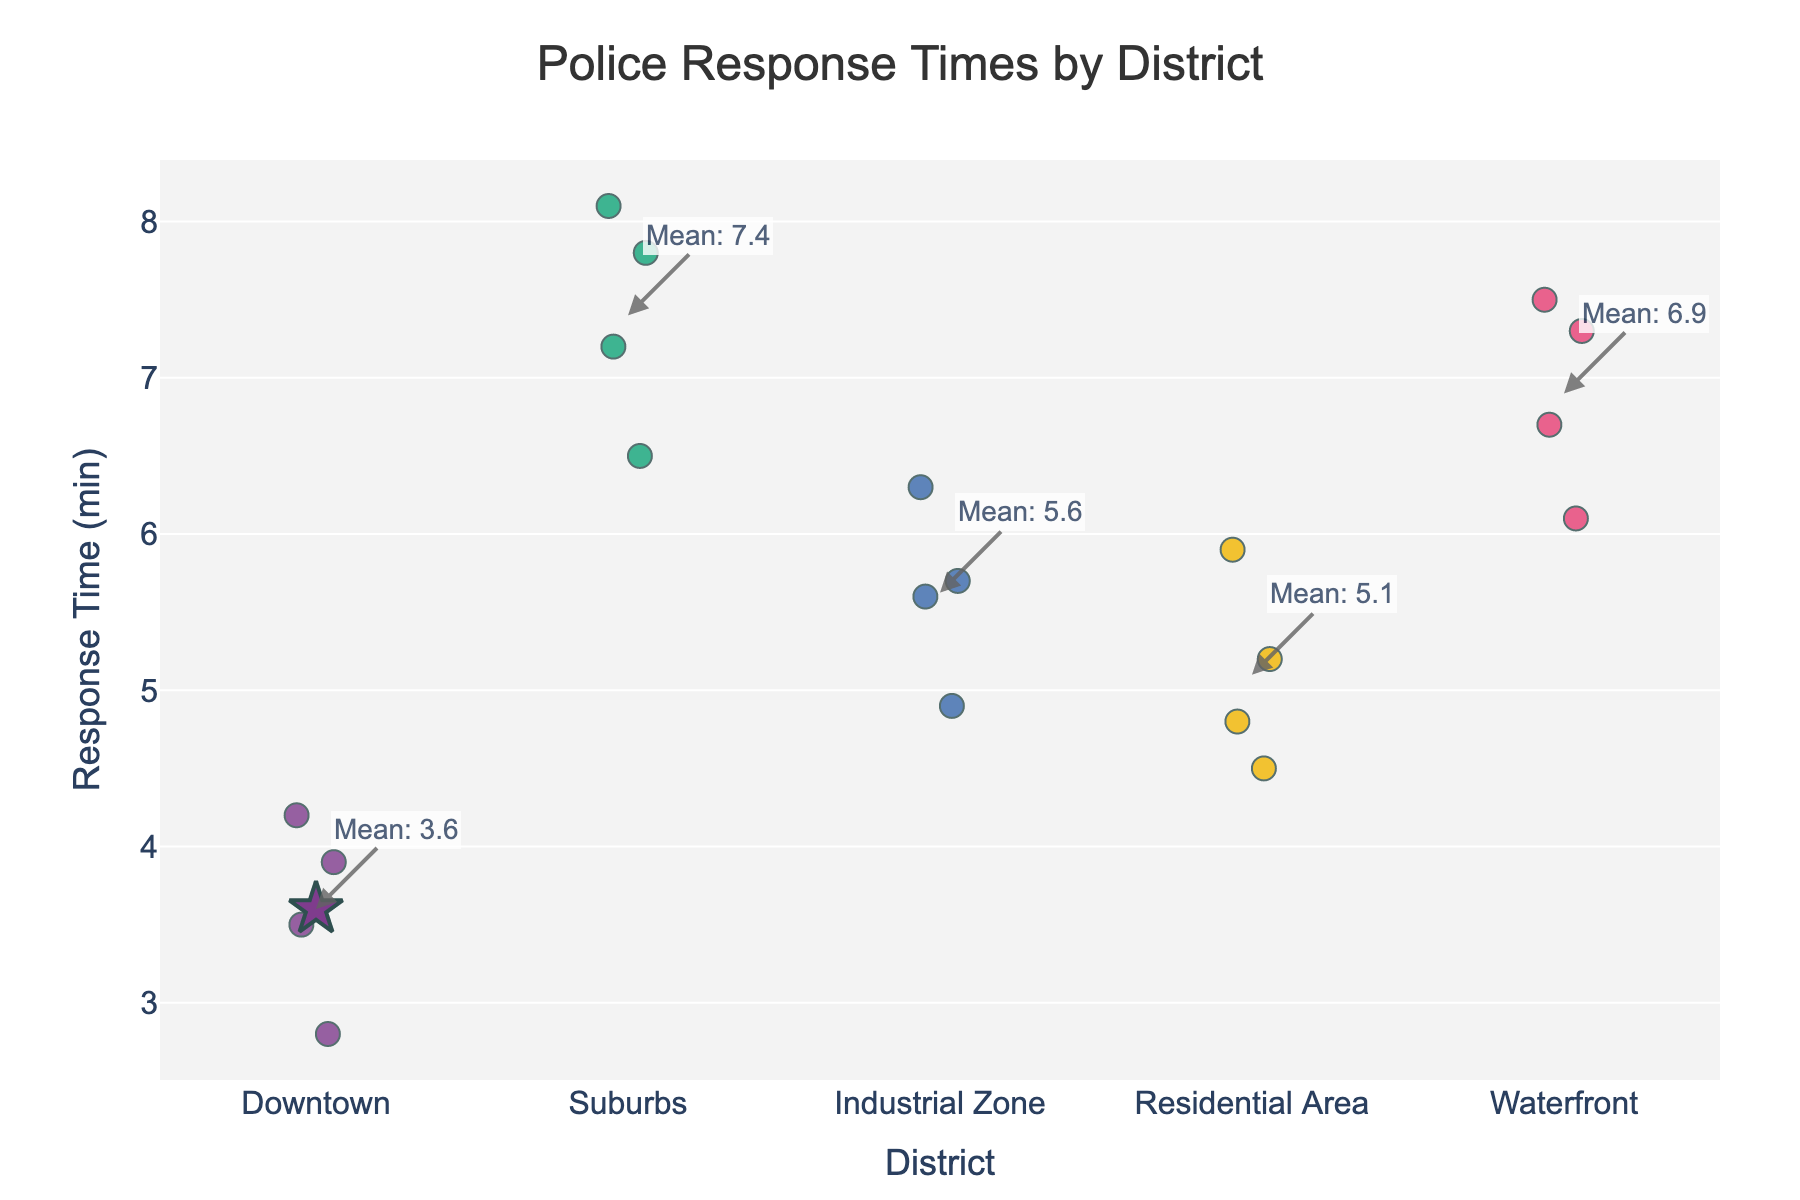What's the title of the figure? The title is displayed at the top center of the plot and provides an overview of what the chart represents, which in this case is related to police response times in different districts.
Answer: Police Response Times by District Which district has the overall shortest mean response time? The mean response times are indicated by star markers and annotated. By comparing these markers, the Downtown district has the lowest mean response time.
Answer: Downtown What is the mean response time for Suburbs? The mean response time for each district is annotated next to the star markers. For Suburbs, the annotation reads "Mean: 7.4", indicating the mean response time.
Answer: 7.4 How many data points are there for the Industrial Zone? Each dot in the strip plot represents a data point. Counting the dots under Industrial Zone gives us the total number of data points for that district.
Answer: 4 Which district has the highest individual response time? The highest individual response time is indicated by the highest dot among all the districts. This dot is located under the Suburbs district with a response time of 8.1 minutes.
Answer: Suburbs How do response times in the Waterfront district compare to those in the Residential Area? Comparing the spread and mean values of response times, Waterfront has higher mean values and individual response times are generally higher compared to the Residential Area.
Answer: Waterfront has higher response times What is the range of the response times in Downtown? The range is determined by the difference between the highest and lowest dots in the Downtown district. The highest is 4.2 minutes and the lowest is 2.8 minutes. The range is 4.2 - 2.8 = 1.4 minutes.
Answer: 1.4 minutes Is there any district with a response time always below 6 minutes? By examining the highest response time for each district, it is noted that only the Downtown district has all its response times below 6 minutes.
Answer: Downtown How much higher is the mean response time in the Waterfront compared to the Residential Area? The mean response time for Waterfront is annotated as 6.9 minutes, and for Residential Area, it is 5.1 minutes. The difference is calculated as 6.9 - 5.1 = 1.8 minutes.
Answer: 1.8 minutes Which district appears to have the most consistent response times? Consistency can be determined by observing the spread of the data points. The Downtown district has closely clustered points, indicating relatively consistent response times.
Answer: Downtown 